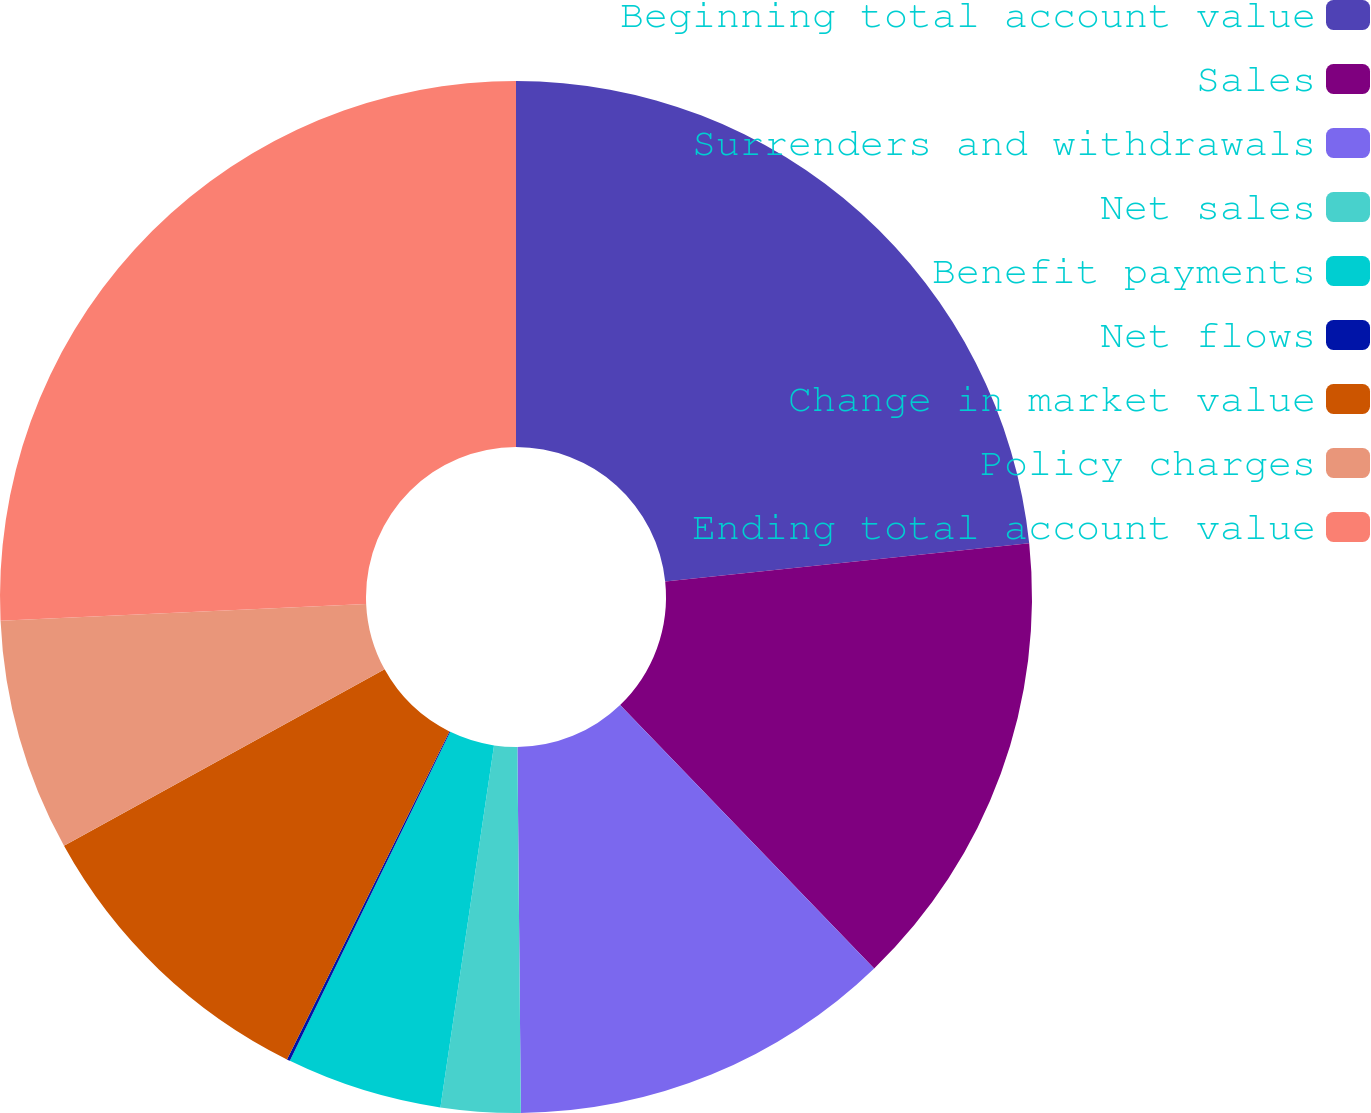Convert chart to OTSL. <chart><loc_0><loc_0><loc_500><loc_500><pie_chart><fcel>Beginning total account value<fcel>Sales<fcel>Surrenders and withdrawals<fcel>Net sales<fcel>Benefit payments<fcel>Net flows<fcel>Change in market value<fcel>Policy charges<fcel>Ending total account value<nl><fcel>23.34%<fcel>14.45%<fcel>12.06%<fcel>2.49%<fcel>4.88%<fcel>0.1%<fcel>9.67%<fcel>7.28%<fcel>25.73%<nl></chart> 